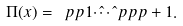Convert formula to latex. <formula><loc_0><loc_0><loc_500><loc_500>\Pi ( x ) = \ p p { 1 } \hat { \cdots } \hat { \ } p p { p + 1 } .</formula> 